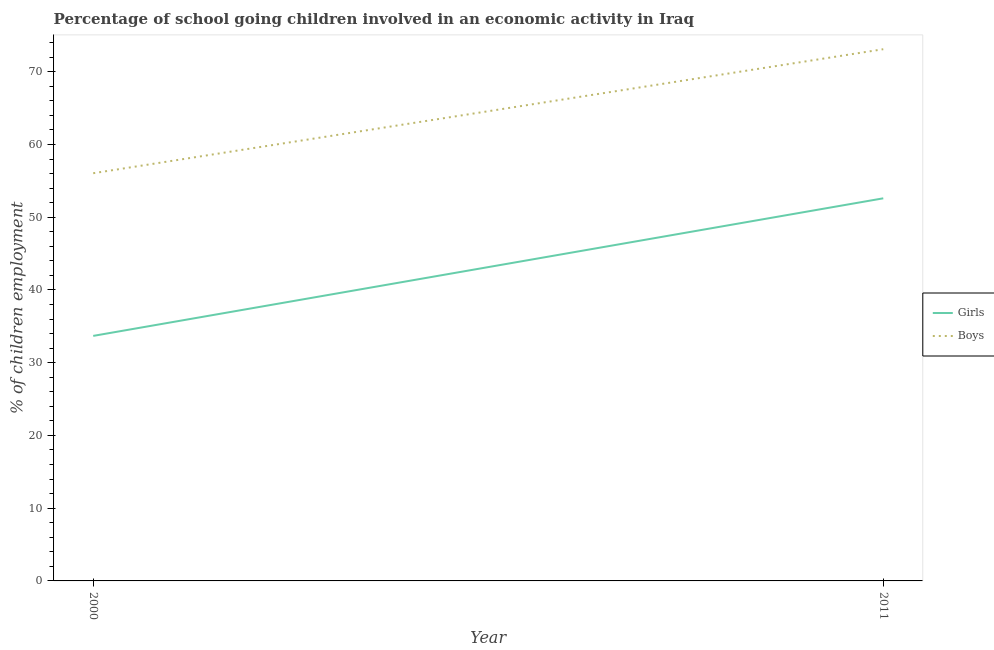What is the percentage of school going girls in 2000?
Your response must be concise. 33.69. Across all years, what is the maximum percentage of school going girls?
Ensure brevity in your answer.  52.6. Across all years, what is the minimum percentage of school going boys?
Make the answer very short. 56.05. In which year was the percentage of school going boys maximum?
Your answer should be compact. 2011. What is the total percentage of school going girls in the graph?
Ensure brevity in your answer.  86.29. What is the difference between the percentage of school going boys in 2000 and that in 2011?
Offer a very short reply. -17.05. What is the difference between the percentage of school going boys in 2011 and the percentage of school going girls in 2000?
Provide a succinct answer. 39.41. What is the average percentage of school going girls per year?
Give a very brief answer. 43.14. In the year 2000, what is the difference between the percentage of school going boys and percentage of school going girls?
Provide a short and direct response. 22.36. In how many years, is the percentage of school going girls greater than 10 %?
Ensure brevity in your answer.  2. What is the ratio of the percentage of school going boys in 2000 to that in 2011?
Your answer should be very brief. 0.77. Is the percentage of school going girls in 2000 less than that in 2011?
Offer a terse response. Yes. In how many years, is the percentage of school going boys greater than the average percentage of school going boys taken over all years?
Ensure brevity in your answer.  1. Does the percentage of school going girls monotonically increase over the years?
Offer a very short reply. Yes. Is the percentage of school going boys strictly greater than the percentage of school going girls over the years?
Keep it short and to the point. Yes. Is the percentage of school going girls strictly less than the percentage of school going boys over the years?
Your answer should be compact. Yes. What is the difference between two consecutive major ticks on the Y-axis?
Offer a very short reply. 10. Does the graph contain grids?
Provide a short and direct response. No. How are the legend labels stacked?
Offer a very short reply. Vertical. What is the title of the graph?
Keep it short and to the point. Percentage of school going children involved in an economic activity in Iraq. Does "Female labor force" appear as one of the legend labels in the graph?
Keep it short and to the point. No. What is the label or title of the X-axis?
Your answer should be compact. Year. What is the label or title of the Y-axis?
Offer a very short reply. % of children employment. What is the % of children employment in Girls in 2000?
Your answer should be very brief. 33.69. What is the % of children employment in Boys in 2000?
Provide a short and direct response. 56.05. What is the % of children employment in Girls in 2011?
Your answer should be compact. 52.6. What is the % of children employment of Boys in 2011?
Ensure brevity in your answer.  73.1. Across all years, what is the maximum % of children employment of Girls?
Offer a very short reply. 52.6. Across all years, what is the maximum % of children employment in Boys?
Keep it short and to the point. 73.1. Across all years, what is the minimum % of children employment in Girls?
Your answer should be compact. 33.69. Across all years, what is the minimum % of children employment of Boys?
Provide a succinct answer. 56.05. What is the total % of children employment of Girls in the graph?
Keep it short and to the point. 86.29. What is the total % of children employment in Boys in the graph?
Provide a short and direct response. 129.15. What is the difference between the % of children employment of Girls in 2000 and that in 2011?
Provide a short and direct response. -18.91. What is the difference between the % of children employment of Boys in 2000 and that in 2011?
Give a very brief answer. -17.05. What is the difference between the % of children employment in Girls in 2000 and the % of children employment in Boys in 2011?
Your answer should be very brief. -39.41. What is the average % of children employment of Girls per year?
Provide a short and direct response. 43.14. What is the average % of children employment of Boys per year?
Keep it short and to the point. 64.58. In the year 2000, what is the difference between the % of children employment of Girls and % of children employment of Boys?
Ensure brevity in your answer.  -22.36. In the year 2011, what is the difference between the % of children employment in Girls and % of children employment in Boys?
Your answer should be compact. -20.5. What is the ratio of the % of children employment of Girls in 2000 to that in 2011?
Your answer should be very brief. 0.64. What is the ratio of the % of children employment in Boys in 2000 to that in 2011?
Offer a very short reply. 0.77. What is the difference between the highest and the second highest % of children employment of Girls?
Make the answer very short. 18.91. What is the difference between the highest and the second highest % of children employment in Boys?
Give a very brief answer. 17.05. What is the difference between the highest and the lowest % of children employment of Girls?
Give a very brief answer. 18.91. What is the difference between the highest and the lowest % of children employment of Boys?
Provide a short and direct response. 17.05. 